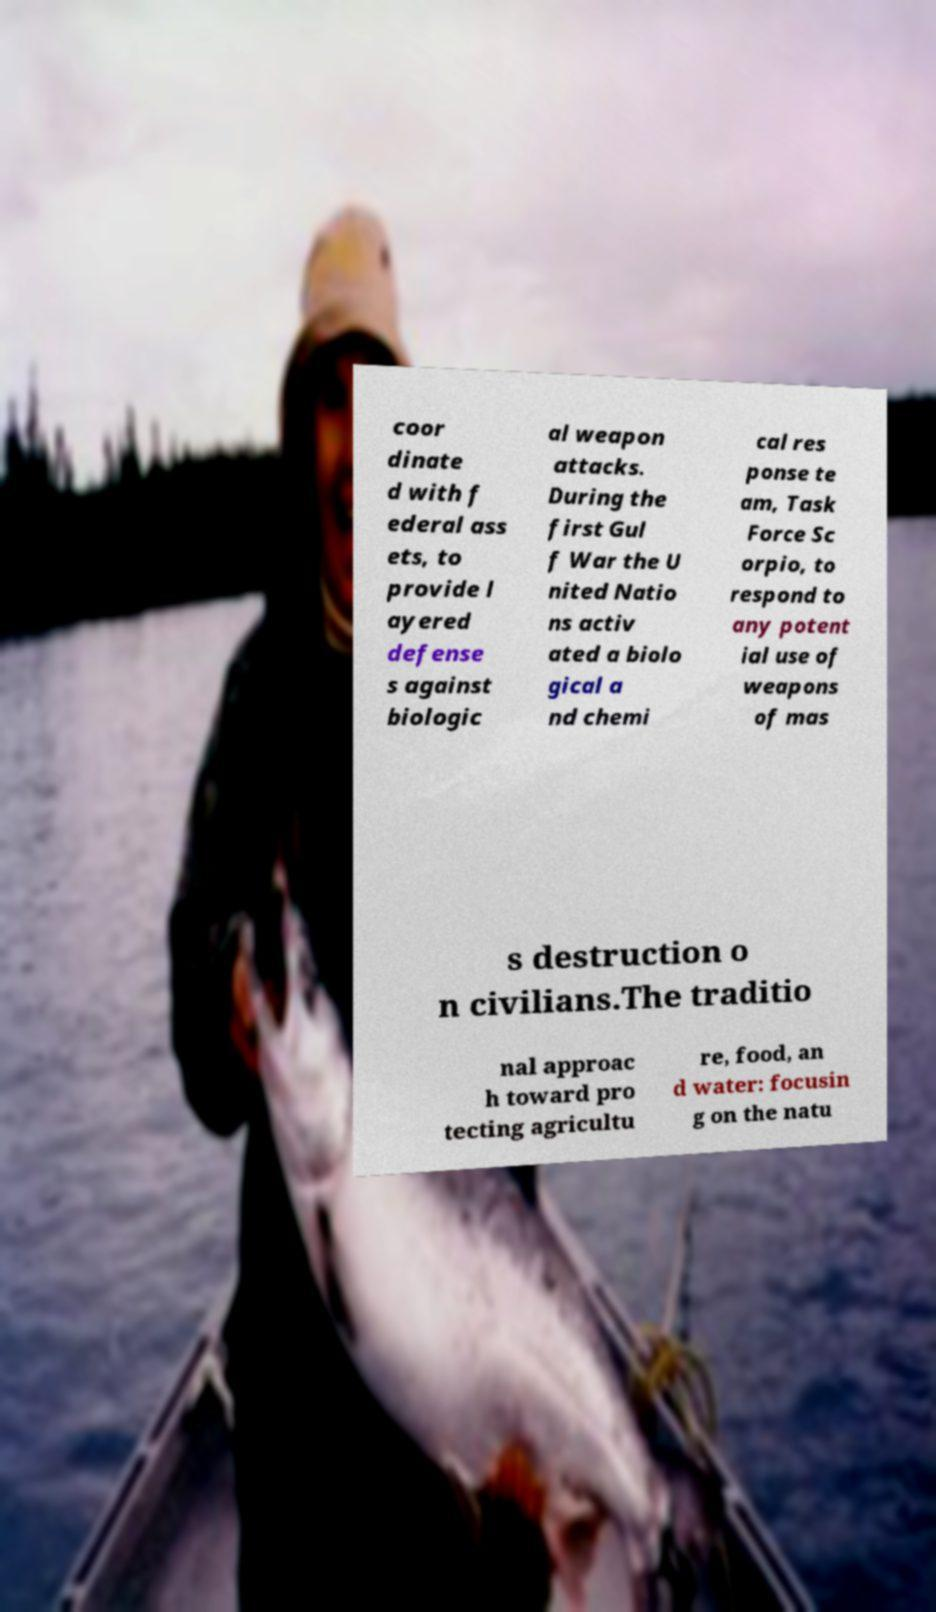Could you extract and type out the text from this image? coor dinate d with f ederal ass ets, to provide l ayered defense s against biologic al weapon attacks. During the first Gul f War the U nited Natio ns activ ated a biolo gical a nd chemi cal res ponse te am, Task Force Sc orpio, to respond to any potent ial use of weapons of mas s destruction o n civilians.The traditio nal approac h toward pro tecting agricultu re, food, an d water: focusin g on the natu 